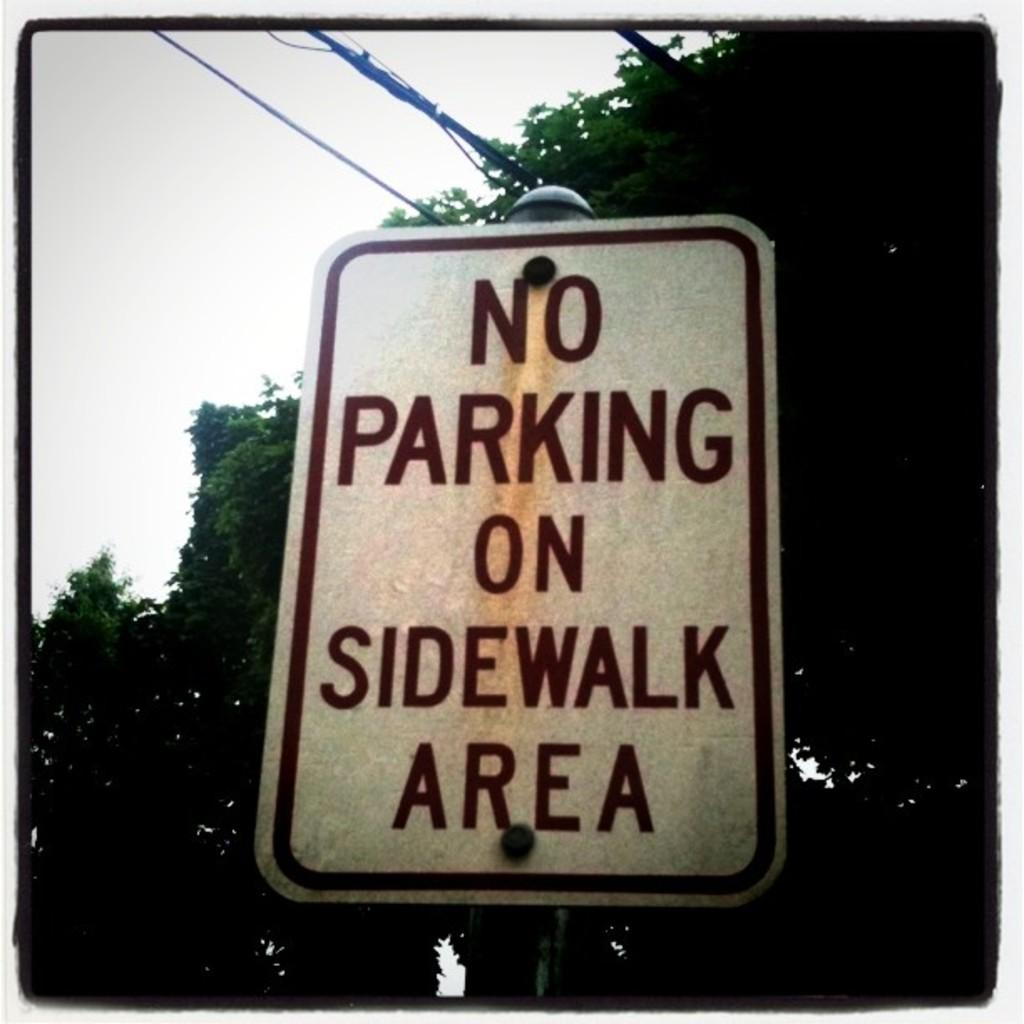<image>
Write a terse but informative summary of the picture. A street sign for no parking on sidewalk area. 